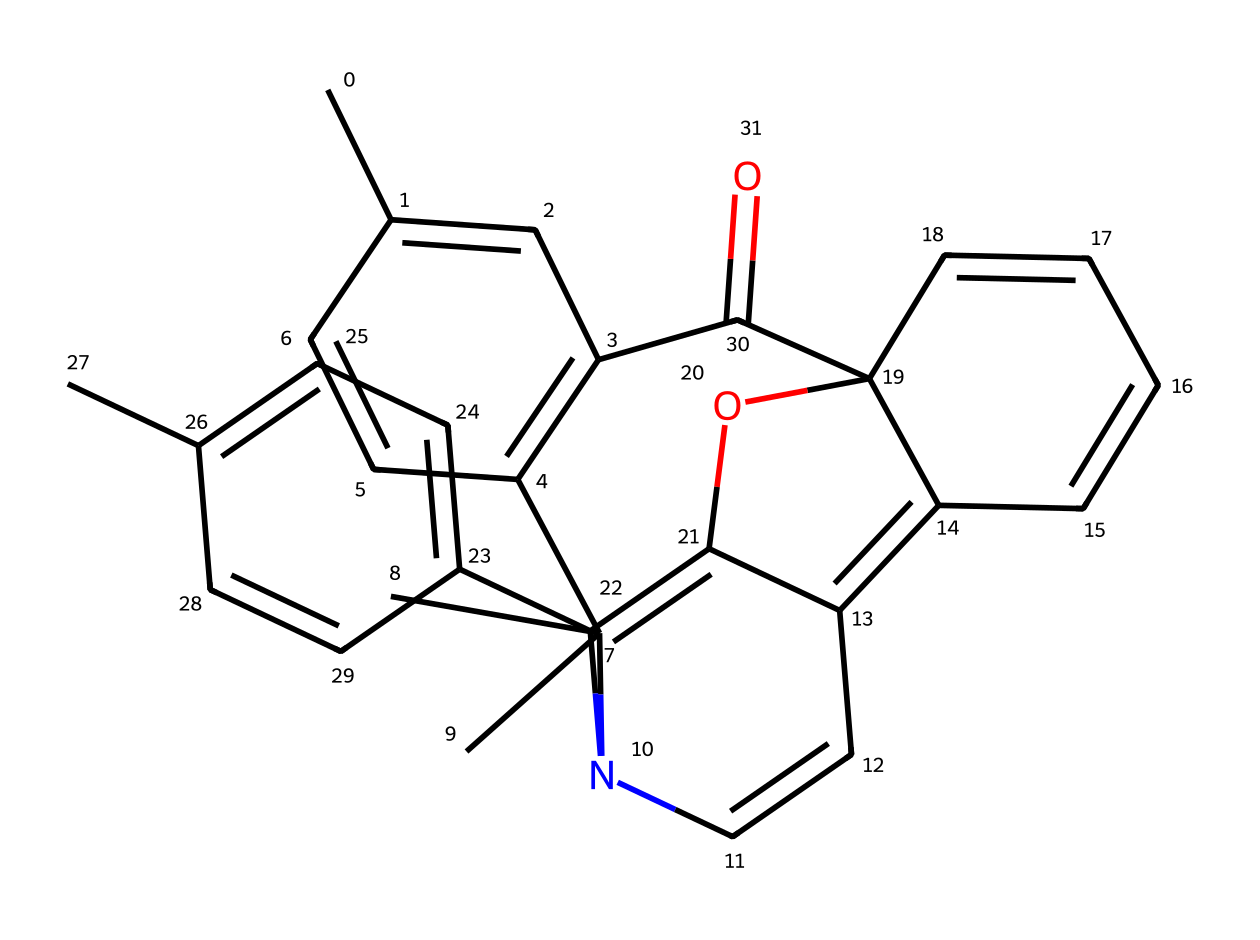What is the total number of carbon atoms in this spiropyran molecule? To find the number of carbon atoms, we count each carbon in the SMILES representation. There are multiple carbon atoms contributing to the overall structure, and by carefully parsing the SMILES, we conclude that there are 25 carbon atoms present.
Answer: 25 How many nitrogen atoms are present in the chemical structure? By examining the SMILES representation, we identify all the nitrogen atoms. In this case, there is only one nitrogen atom contributing to the structure of spiropyran.
Answer: 1 What type of bonding is primarily responsible for the photochromic properties of spiropyran? The photochromic properties arise from alternating single and double bonds (conjugation) in the structure, facilitating electron transitions when exposed to light. This structural feature is crucial to its ability to change color.
Answer: conjugation What functional group is evident in this spiropyran structure? Analyzing the SMILES, we observe that there is an ether functional group present, indicated by the part of the structure holding the oxygen atom connected between two carbon atoms. This group is crucial for its reactions and properties.
Answer: ether How does the structure of spiropyran enable its function as a photochromic lens? The specific arrangement of the conjugated double bonds allows for significant changes in molecular structure upon exposure to light, resulting in a reversible color change. This capability makes it suitable for use in sunglasses and lenses.
Answer: reversible color change How many rings are contained in the spiropyran molecule? By scrutinizing the structure reflected in the SMILES, we observe that there are four distinct rings in the spiropyran molecule, contributing to its complex structure and properties.
Answer: 4 